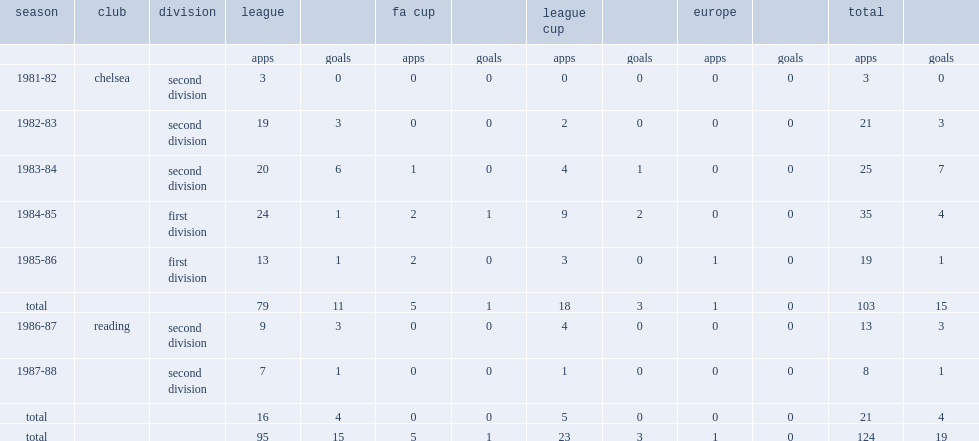Which division did paul canoville sign with chelsea in 1981 and appeare in 1983-84? Second division. 